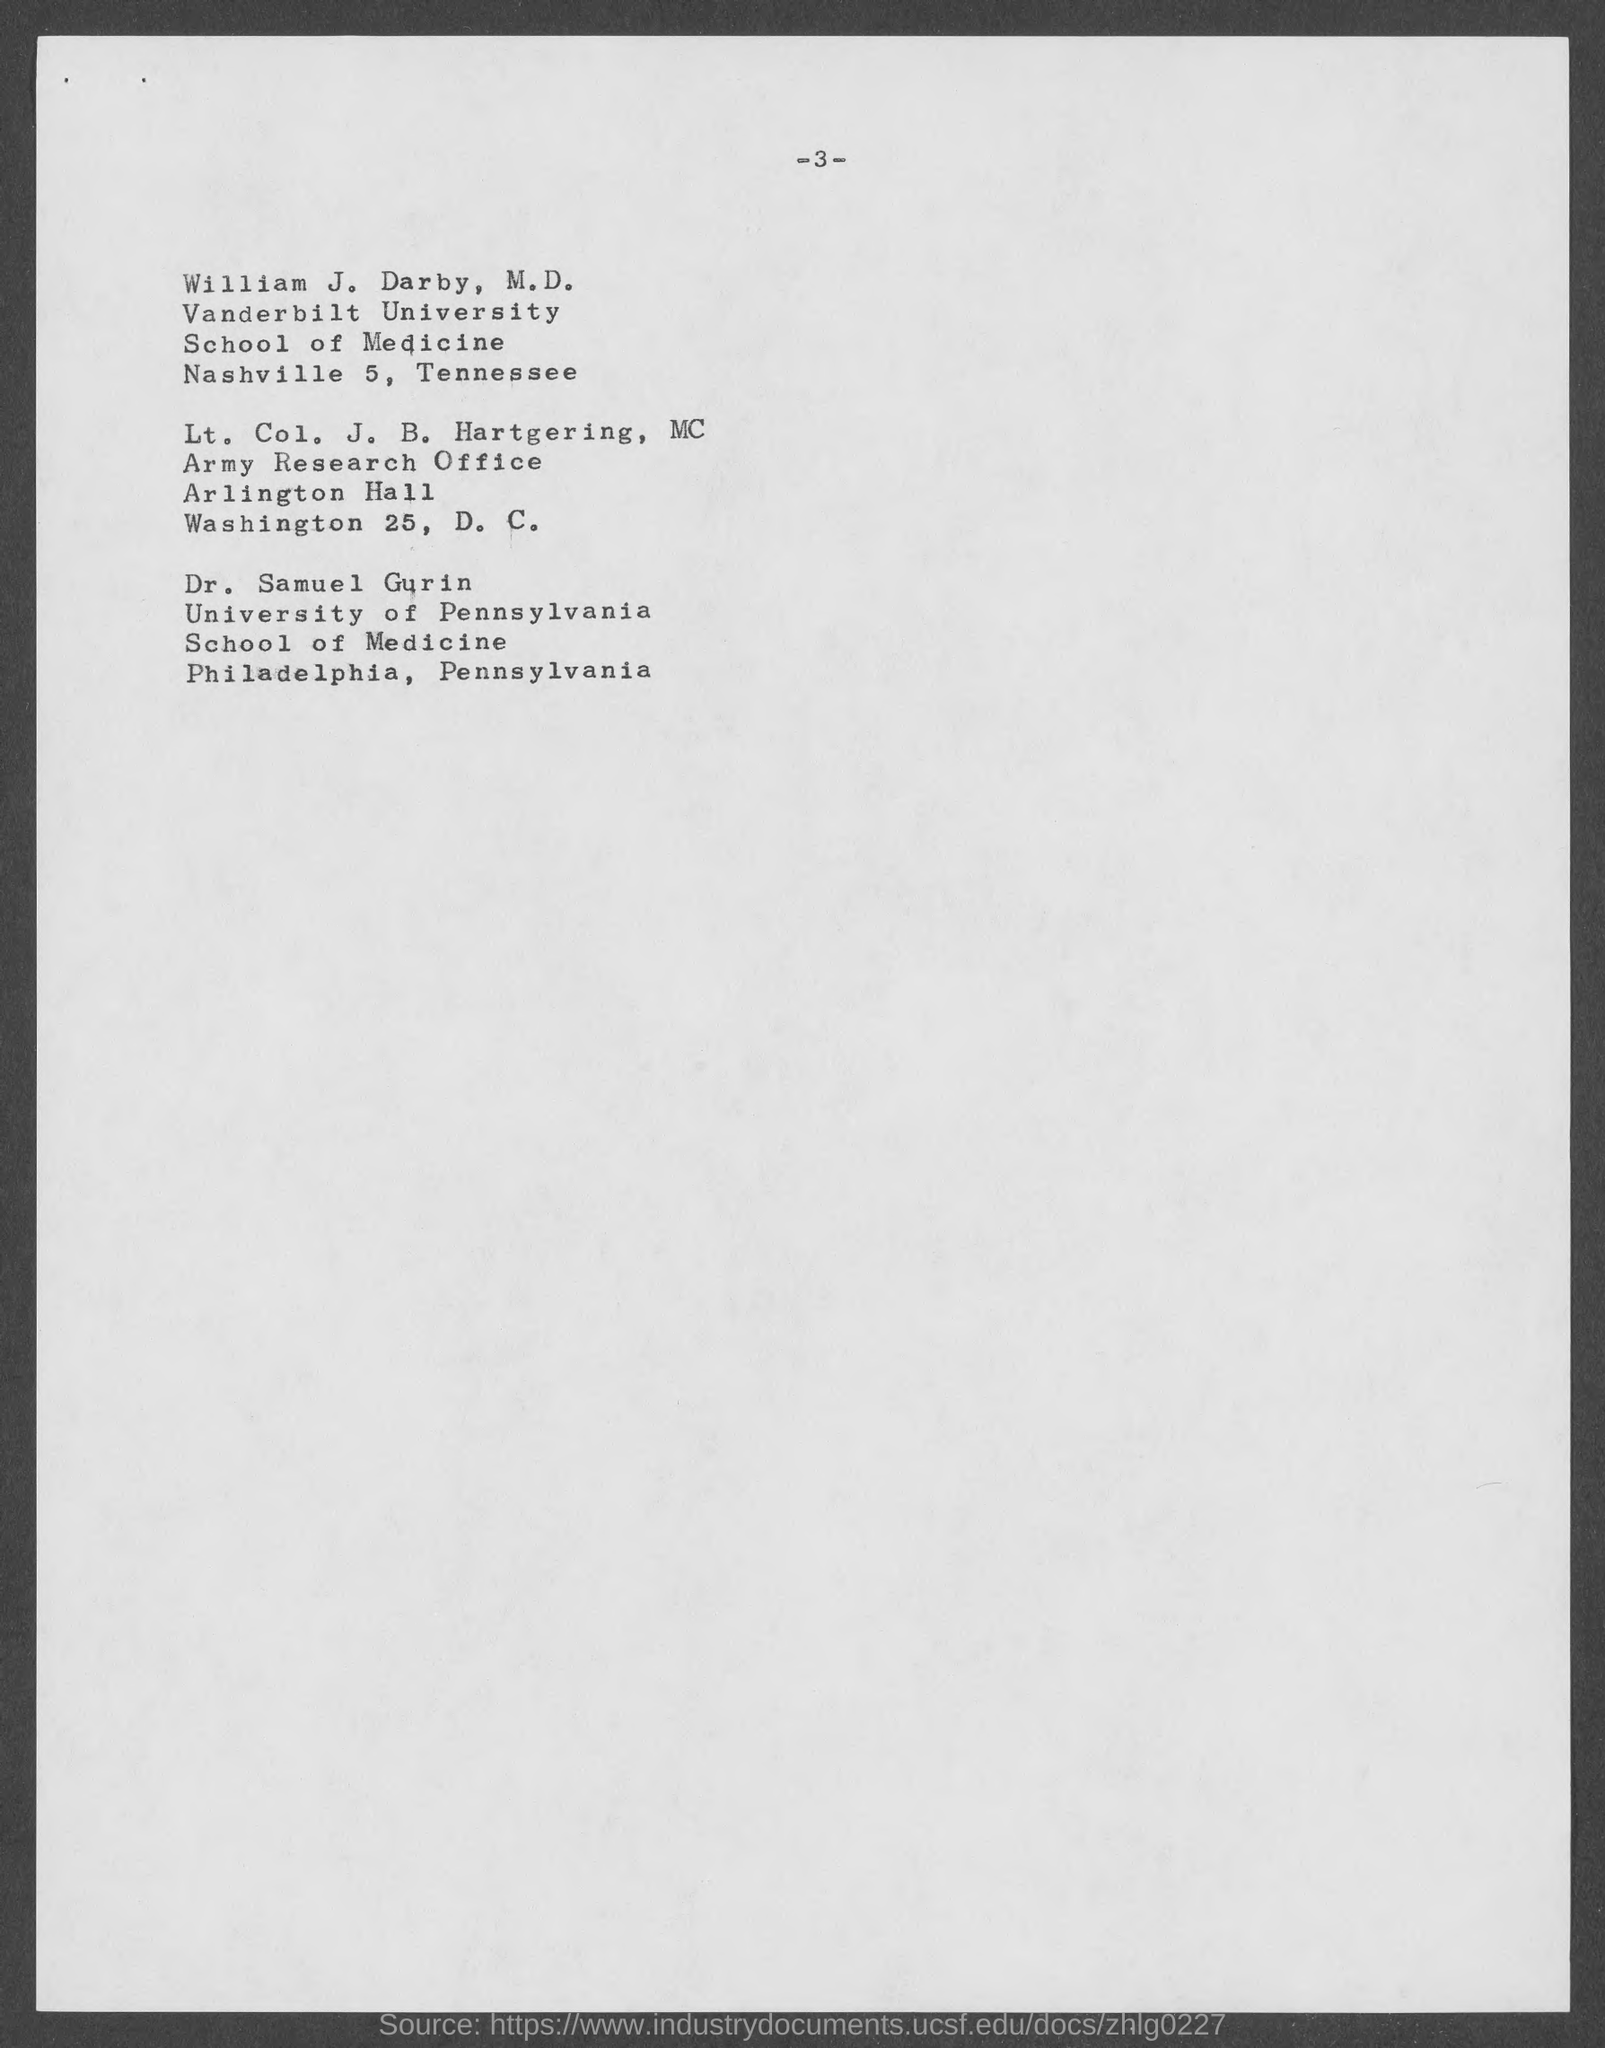Specify some key components in this picture. William J. Darby is a student of Vanderbilt University. Dr. Samuel Gurin belongs to the University of Pennsylvania. The page number at the top of the page is 3 